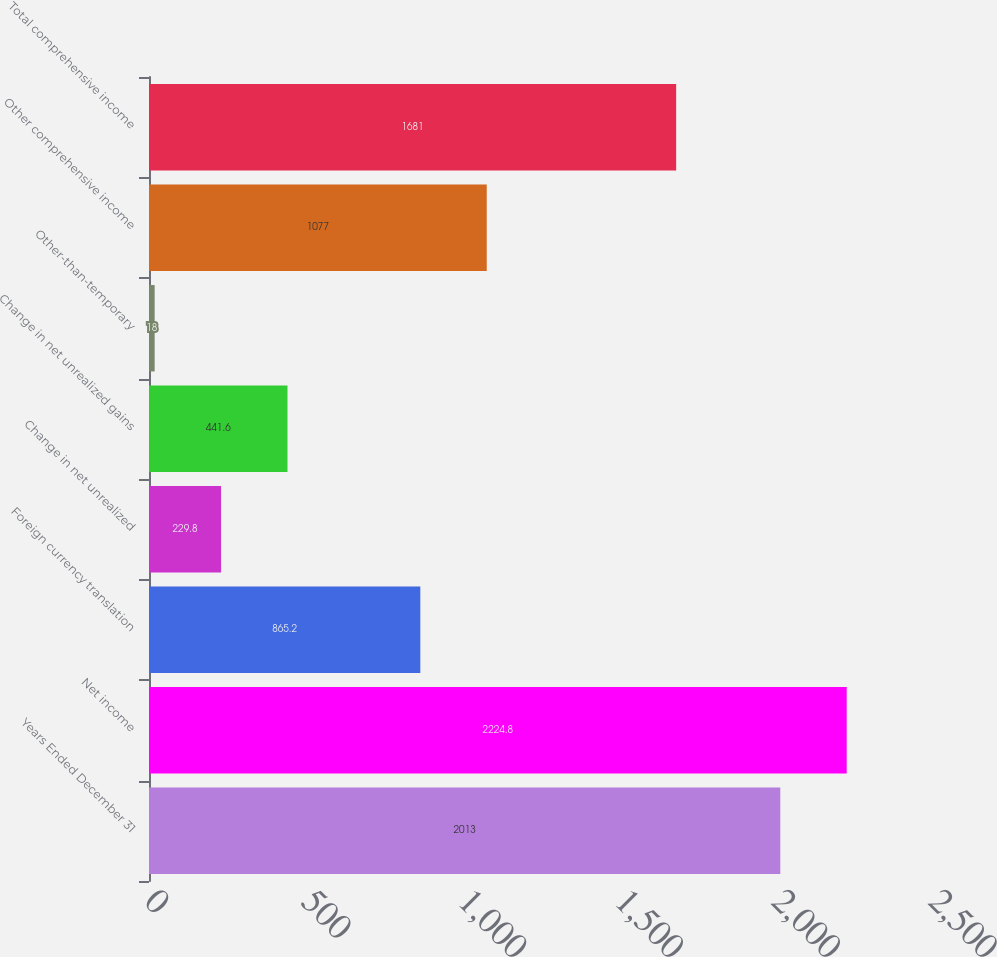Convert chart to OTSL. <chart><loc_0><loc_0><loc_500><loc_500><bar_chart><fcel>Years Ended December 31<fcel>Net income<fcel>Foreign currency translation<fcel>Change in net unrealized<fcel>Change in net unrealized gains<fcel>Other-than-temporary<fcel>Other comprehensive income<fcel>Total comprehensive income<nl><fcel>2013<fcel>2224.8<fcel>865.2<fcel>229.8<fcel>441.6<fcel>18<fcel>1077<fcel>1681<nl></chart> 